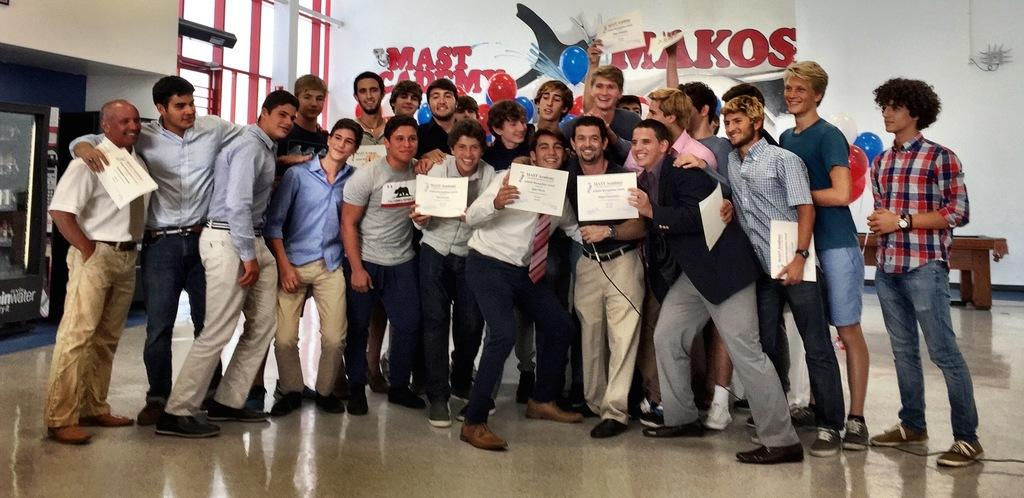How many people are in the image? There is a group of people standing in the image. What can be seen in the background of the image? There is a wall in the background of the image. What is written on the wall? There is something written on the wall. What is the wooden object on the floor in the image? There is a wooden object on the floor in the image. Can you hear the sound of the ring at the seashore in the image? There is no sound or seashore present in the image; it is a group of people standing with a wall and a wooden object in the background. 